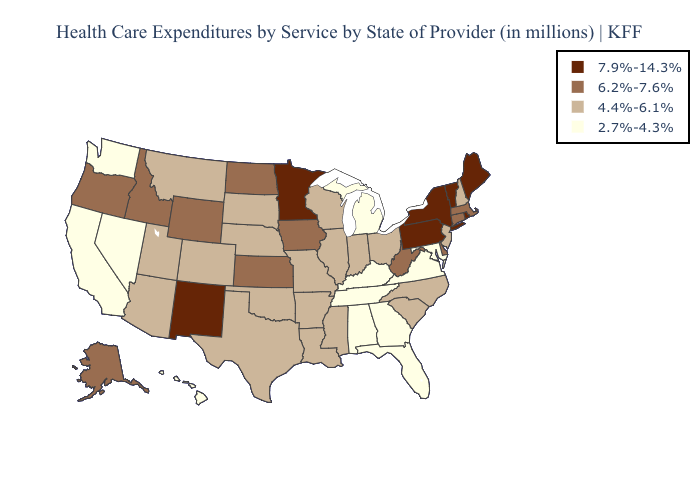Does Michigan have a lower value than Georgia?
Be succinct. No. Does Washington have the highest value in the USA?
Concise answer only. No. What is the value of Montana?
Quick response, please. 4.4%-6.1%. Name the states that have a value in the range 4.4%-6.1%?
Answer briefly. Arizona, Arkansas, Colorado, Illinois, Indiana, Louisiana, Mississippi, Missouri, Montana, Nebraska, New Hampshire, New Jersey, North Carolina, Ohio, Oklahoma, South Carolina, South Dakota, Texas, Utah, Wisconsin. What is the value of Wyoming?
Concise answer only. 6.2%-7.6%. What is the value of Nebraska?
Answer briefly. 4.4%-6.1%. Among the states that border Missouri , does Nebraska have the highest value?
Short answer required. No. Does Kentucky have the lowest value in the South?
Give a very brief answer. Yes. Does the map have missing data?
Answer briefly. No. How many symbols are there in the legend?
Concise answer only. 4. Name the states that have a value in the range 4.4%-6.1%?
Write a very short answer. Arizona, Arkansas, Colorado, Illinois, Indiana, Louisiana, Mississippi, Missouri, Montana, Nebraska, New Hampshire, New Jersey, North Carolina, Ohio, Oklahoma, South Carolina, South Dakota, Texas, Utah, Wisconsin. Name the states that have a value in the range 7.9%-14.3%?
Short answer required. Maine, Minnesota, New Mexico, New York, Pennsylvania, Rhode Island, Vermont. Among the states that border Vermont , does New Hampshire have the highest value?
Quick response, please. No. Which states hav the highest value in the Northeast?
Write a very short answer. Maine, New York, Pennsylvania, Rhode Island, Vermont. What is the lowest value in the USA?
Write a very short answer. 2.7%-4.3%. 